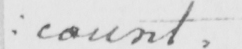What is written in this line of handwriting? : count . 